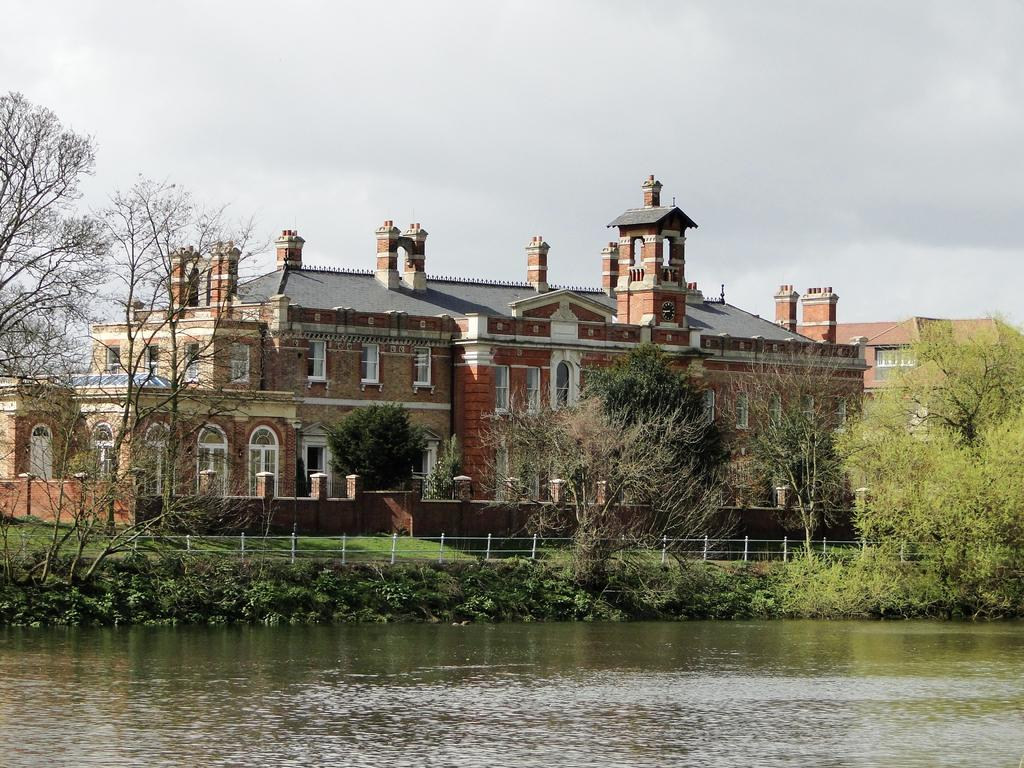What type of natural environment is depicted in the image? The image contains water, grass, trees, and the sky, which suggests a natural environment. What type of man-made structures are present in the image? There are buildings in the image. What separates the natural environment from the man-made structures? There is a fence in the image that separates the natural environment from the man-made structures. What type of pump can be seen in the image? There is no pump present in the image. How does the water in the image react to someone sneezing nearby? There is no indication in the image that someone is sneezing nearby, so it's not possible to determine how the water would react. 